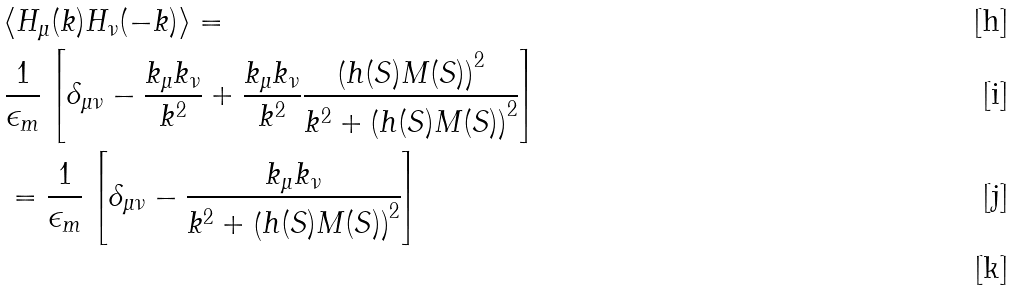<formula> <loc_0><loc_0><loc_500><loc_500>& \langle H _ { \mu } ( k ) H _ { \nu } ( - k ) \rangle = \\ & \frac { 1 } { \epsilon _ { m } } \left [ \delta _ { \mu \nu } - \frac { k _ { \mu } k _ { \nu } } { k ^ { 2 } } + \frac { k _ { \mu } k _ { \nu } } { k ^ { 2 } } \frac { \left ( h ( S ) M ( S ) \right ) ^ { 2 } } { k ^ { 2 } + \left ( h ( S ) M ( S ) \right ) ^ { 2 } } \right ] \\ & = \frac { 1 } { \epsilon _ { m } } \left [ \delta _ { \mu \nu } - \frac { k _ { \mu } k _ { \nu } } { k ^ { 2 } + \left ( h ( S ) M ( S ) \right ) ^ { 2 } } \right ] \\</formula> 